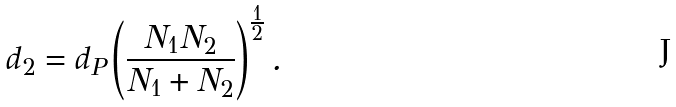<formula> <loc_0><loc_0><loc_500><loc_500>d _ { 2 } = d _ { P } \left ( \frac { N _ { 1 } N _ { 2 } } { N _ { 1 } + N _ { 2 } } \right ) ^ { \frac { 1 } { 2 } } .</formula> 